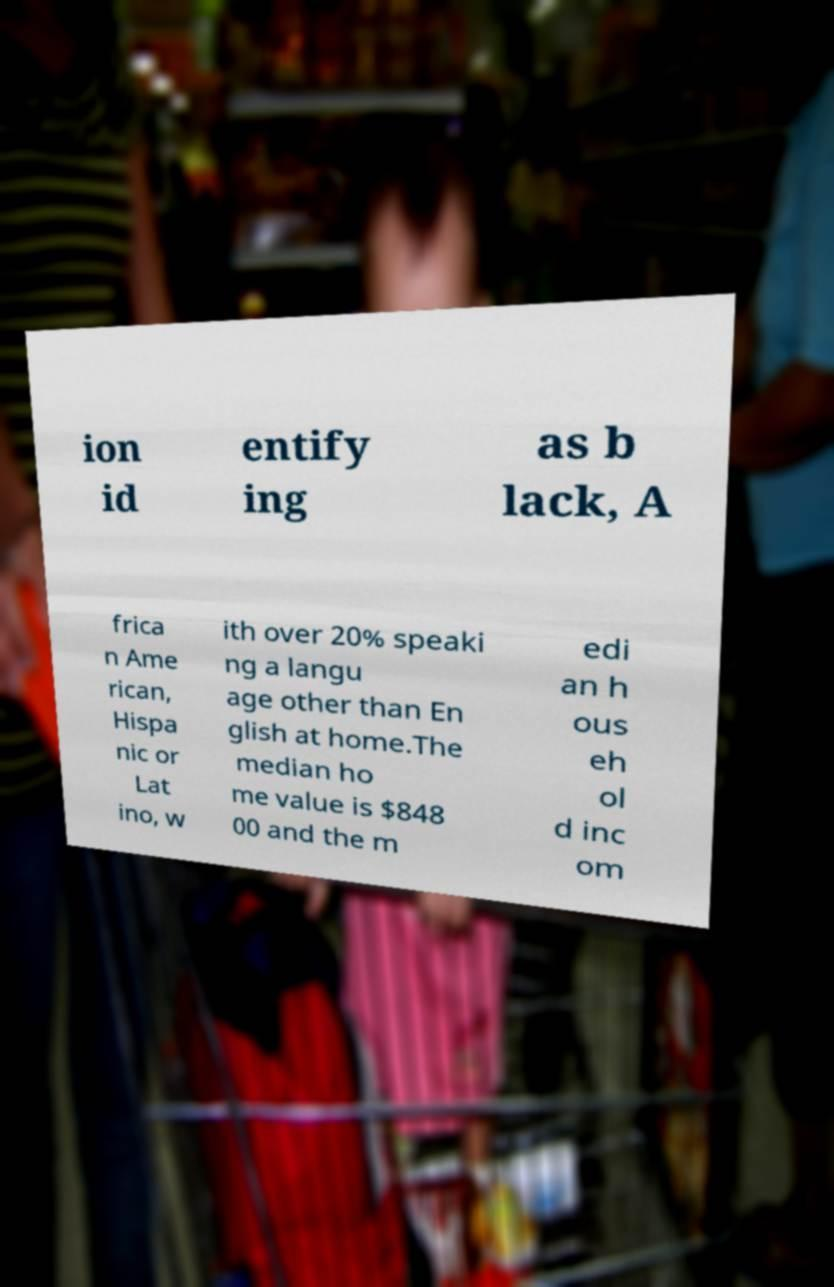Can you read and provide the text displayed in the image?This photo seems to have some interesting text. Can you extract and type it out for me? ion id entify ing as b lack, A frica n Ame rican, Hispa nic or Lat ino, w ith over 20% speaki ng a langu age other than En glish at home.The median ho me value is $848 00 and the m edi an h ous eh ol d inc om 